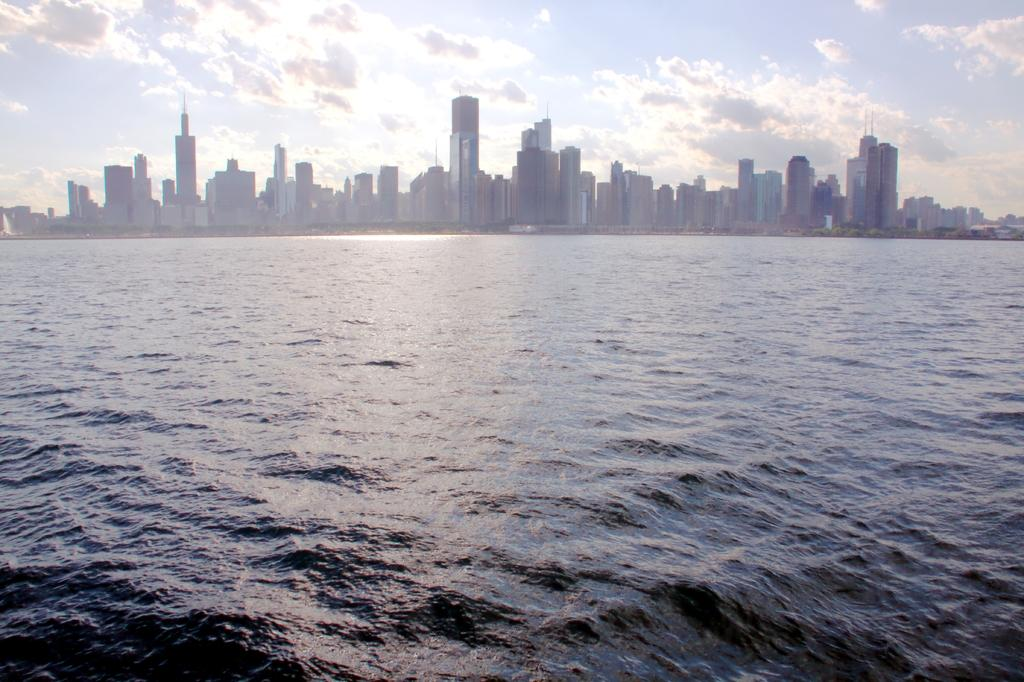What is the primary element visible in the image? There is water in the image. What type of structures can be seen in the image? There are buildings and skyscrapers in the image. What is visible above the buildings and water? There is a sky visible in the image. Can you see a monkey using its tongue to catch the light in the image? There is no monkey or light present in the image, so this scenario cannot be observed. 